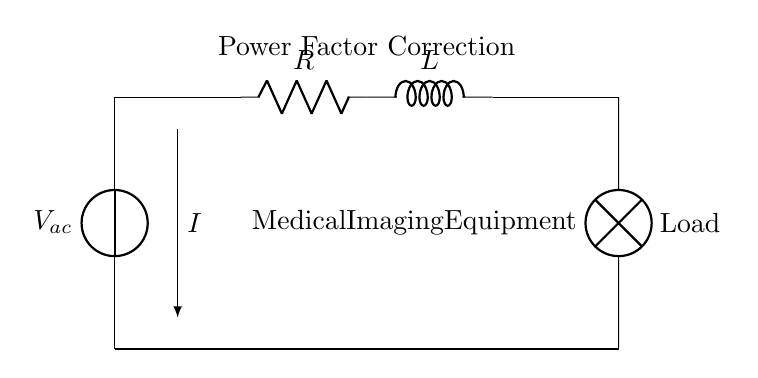What type of circuit is shown? The circuit consists of a resistor and an inductor arranged in series, which characterizes it as an RL circuit.
Answer: RL circuit What is the purpose of the circuit in a medical context? The circuit is designed for power factor correction, which improves the efficiency of the power supply to medical imaging equipment.
Answer: Power factor correction What component is labeled as 'R'? 'R' refers to the resistor, which limits the current flowing through the circuit.
Answer: Resistor What does 'L' represent in the circuit? 'L' represents the inductor, which stores energy in a magnetic field when electrical current passes through it.
Answer: Inductor What is the direction of the current denoted by 'I'? The arrow indicates that current flows from the voltage source, through the circuit, indicating the direction of conventional current flow.
Answer: From source to load How does this RL circuit influence power factor? The RL circuit modifies the phase angle between voltage and current, effectively correcting the power factor to enhance energy efficiency.
Answer: It corrects the power factor What kind of load is connected to this circuit? The load connected is a medical imaging equipment, which requires a stable power supply for optimal operation.
Answer: Medical imaging equipment 